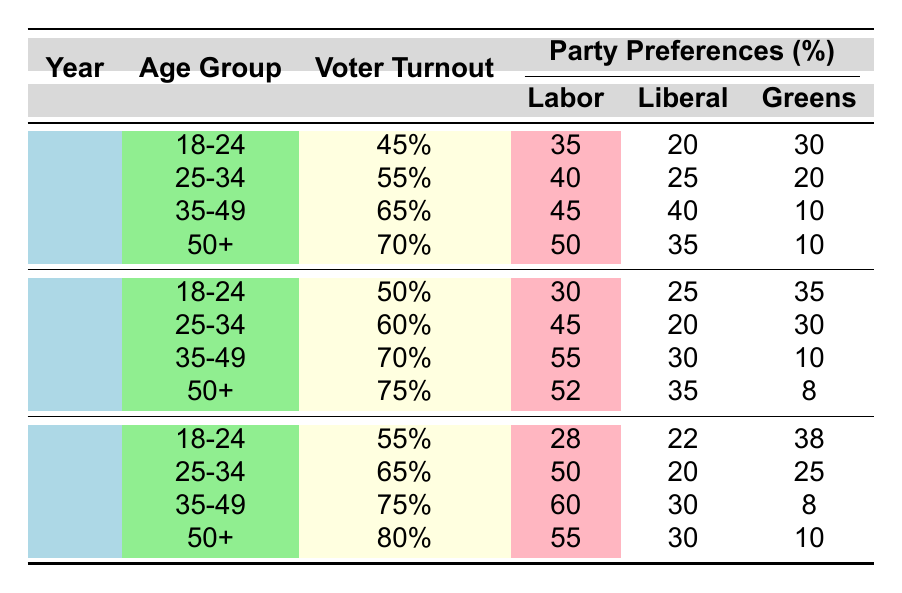What was the voter turnout for the age group 18-24 in the 2022 election? The voter turnout for the age group 18-24 in the 2022 election is listed directly in the table as 55%.
Answer: 55% Which party received the highest percentage of votes in the 35-49 age group during the 2018 election? In the 2018 election for the 35-49 age group, Labor received the highest percentage of votes at 55% as seen in the table.
Answer: Labor What is the average voter turnout for the 50+ age group across the three election years? To calculate the average for the 50+ age group: add 70% (2014) + 75% (2018) + 80% (2022) = 225%, then divide by 3, which gives an average of 75%.
Answer: 75% Did the preference for the Liberal party among the 25-34 age group increase or decrease from 2014 to 2022? In 2014, the preference for the Liberal party was 25%, while in 2022 it is 20%. This indicates a decrease in preference.
Answer: Decrease What is the total percentage of votes for the 'Others' category in the 18-24 age group over all three elections? Summing the 'Others' category for the age group 18-24 gives: 15% (2014) + 10% (2018) + 12% (2022) = 37%.
Answer: 37% Which age group showed the highest increase in voter turnout from 2014 to 2022? Comparing the voter turnout for each age group from 2014 to 2022: 18-24 increased from 45% to 55% (10%), 25-34 from 55% to 65% (10%), 35-49 from 65% to 75% (10%), and 50+ from 70% to 80% (10%). Therefore, all age groups had the same increase of 10%.
Answer: All age groups In which election year did the Greens receive their lowest percentage of preference in the table? According to the table, the Greens received their lowest percentage of preference in the 35-49 age group during the 2018 election at 10%.
Answer: 2018 Was the voter turnout for the 35-49 age group higher in 2022 compared to the 25-34 age group in the same year? The voter turnout for the 35-49 age group in 2022 is 75%, which is higher than the 25-34 age group's turnout of 65% in the same year.
Answer: Yes 